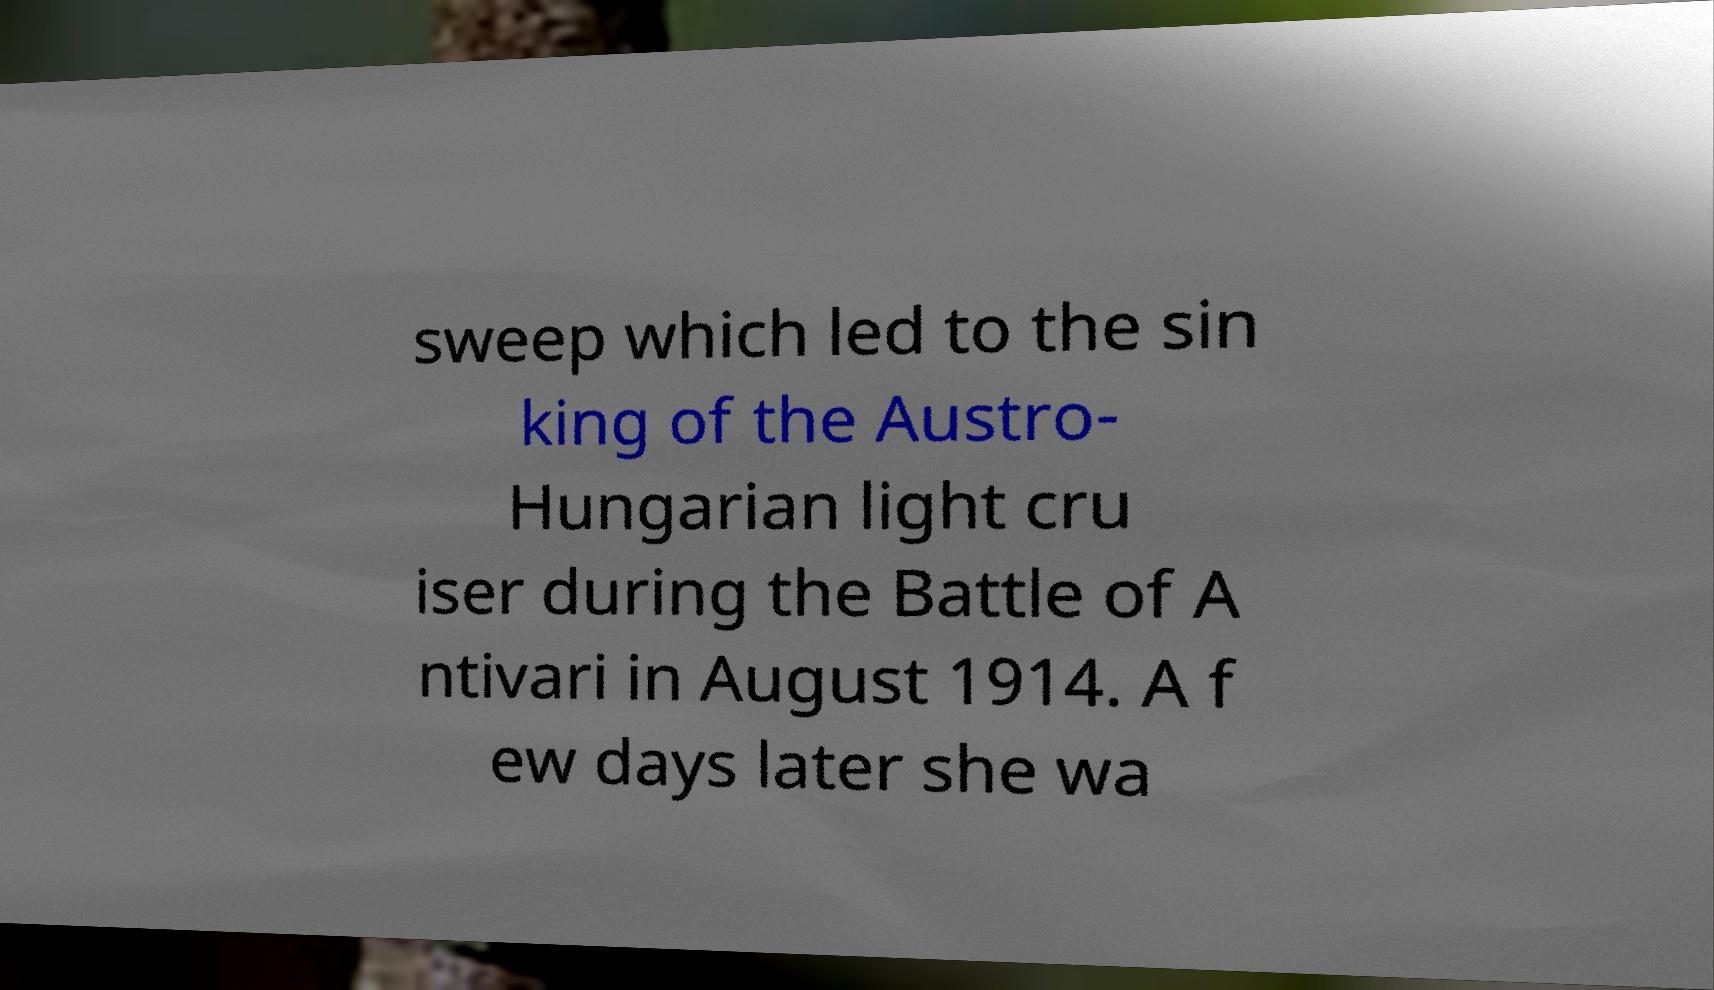For documentation purposes, I need the text within this image transcribed. Could you provide that? sweep which led to the sin king of the Austro- Hungarian light cru iser during the Battle of A ntivari in August 1914. A f ew days later she wa 